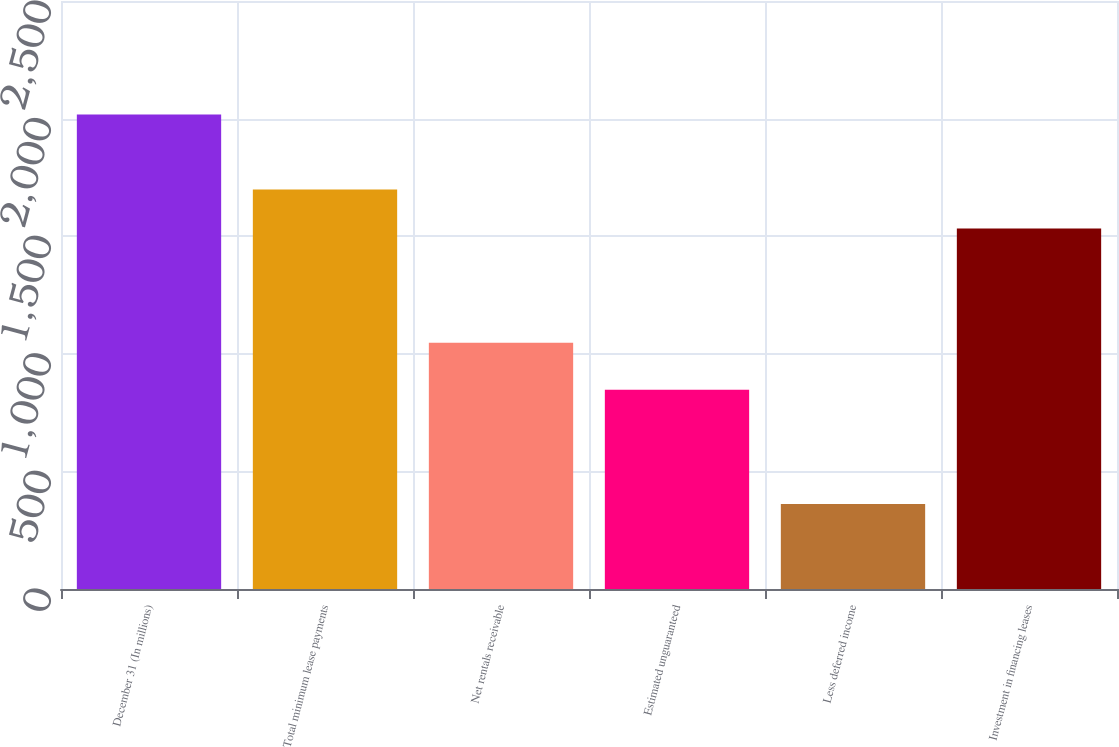Convert chart to OTSL. <chart><loc_0><loc_0><loc_500><loc_500><bar_chart><fcel>December 31 (In millions)<fcel>Total minimum lease payments<fcel>Net rentals receivable<fcel>Estimated unguaranteed<fcel>Less deferred income<fcel>Investment in financing leases<nl><fcel>2017<fcel>1698.6<fcel>1047<fcel>847<fcel>361<fcel>1533<nl></chart> 